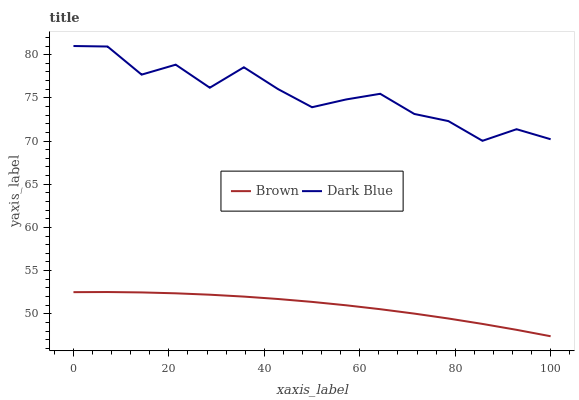Does Brown have the minimum area under the curve?
Answer yes or no. Yes. Does Dark Blue have the maximum area under the curve?
Answer yes or no. Yes. Does Dark Blue have the minimum area under the curve?
Answer yes or no. No. Is Brown the smoothest?
Answer yes or no. Yes. Is Dark Blue the roughest?
Answer yes or no. Yes. Is Dark Blue the smoothest?
Answer yes or no. No. Does Brown have the lowest value?
Answer yes or no. Yes. Does Dark Blue have the lowest value?
Answer yes or no. No. Does Dark Blue have the highest value?
Answer yes or no. Yes. Is Brown less than Dark Blue?
Answer yes or no. Yes. Is Dark Blue greater than Brown?
Answer yes or no. Yes. Does Brown intersect Dark Blue?
Answer yes or no. No. 